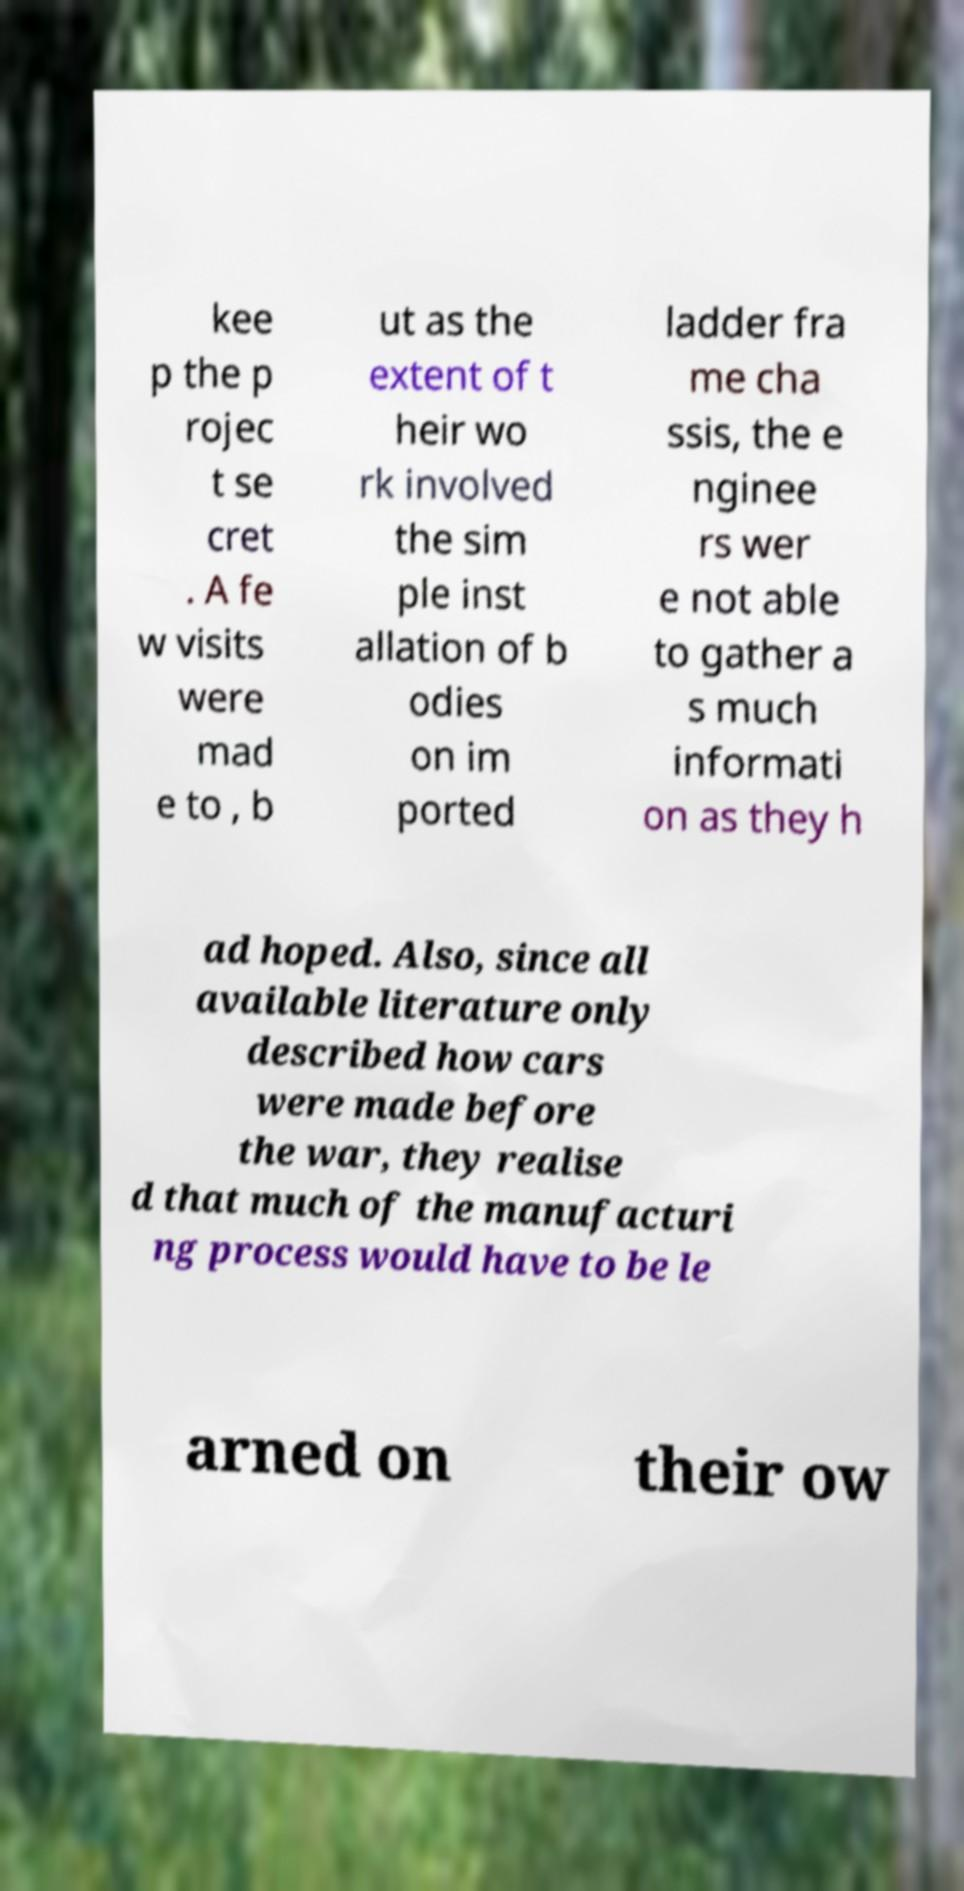Can you accurately transcribe the text from the provided image for me? kee p the p rojec t se cret . A fe w visits were mad e to , b ut as the extent of t heir wo rk involved the sim ple inst allation of b odies on im ported ladder fra me cha ssis, the e nginee rs wer e not able to gather a s much informati on as they h ad hoped. Also, since all available literature only described how cars were made before the war, they realise d that much of the manufacturi ng process would have to be le arned on their ow 